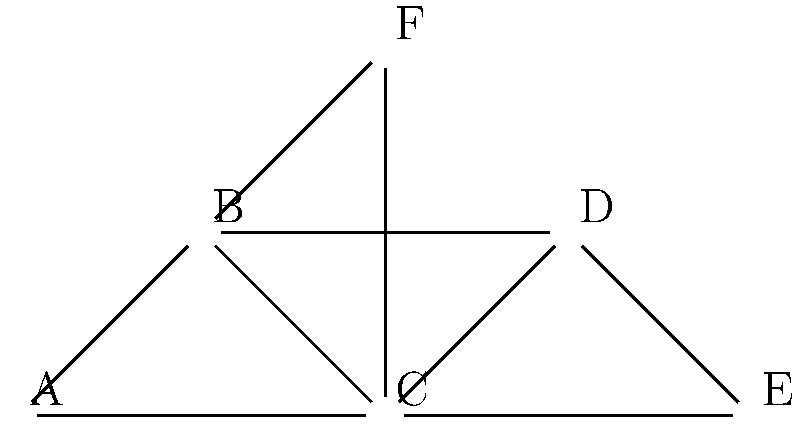In the given epidemic spread network, which node has the highest betweenness centrality and is therefore most critical for controlling the spread of an infection? Justify your answer using the concept of betweenness centrality in the context of epidemic modeling. To identify the node with the highest betweenness centrality, we need to follow these steps:

1. Understand betweenness centrality:
   Betweenness centrality measures the extent to which a node lies on the shortest paths between other nodes in the network. It is calculated as:

   $$BC(v) = \sum_{s \neq v \neq t} \frac{\sigma_{st}(v)}{\sigma_{st}}$$

   where $\sigma_{st}$ is the total number of shortest paths from node $s$ to node $t$, and $\sigma_{st}(v)$ is the number of those paths that pass through $v$.

2. Analyze the network structure:
   - The network has 6 nodes (A, B, C, D, E, F) with various connections.
   - Node C appears to be centrally located and connected to all other nodes except E.

3. Consider shortest paths:
   - Many shortest paths between pairs of nodes pass through C.
   - For example, the shortest path from A to E goes through C.

4. Compare with other nodes:
   - Node B is also well-connected but doesn't lie on as many shortest paths as C.
   - Nodes A and E are peripheral and have low betweenness.
   - Nodes D and F have moderate connectivity but fewer shortest paths than C.

5. Interpret in the context of epidemic modeling:
   - A node with high betweenness centrality acts as a bridge between different parts of the network.
   - In epidemic spread, such nodes are crucial for transmission between otherwise disconnected clusters.
   - Controlling or monitoring these nodes can significantly impact the spread of an infection.

6. Conclusion:
   Node C has the highest betweenness centrality due to its central position and involvement in many shortest paths. It is therefore the most critical node for controlling epidemic spread in this network.
Answer: Node C 